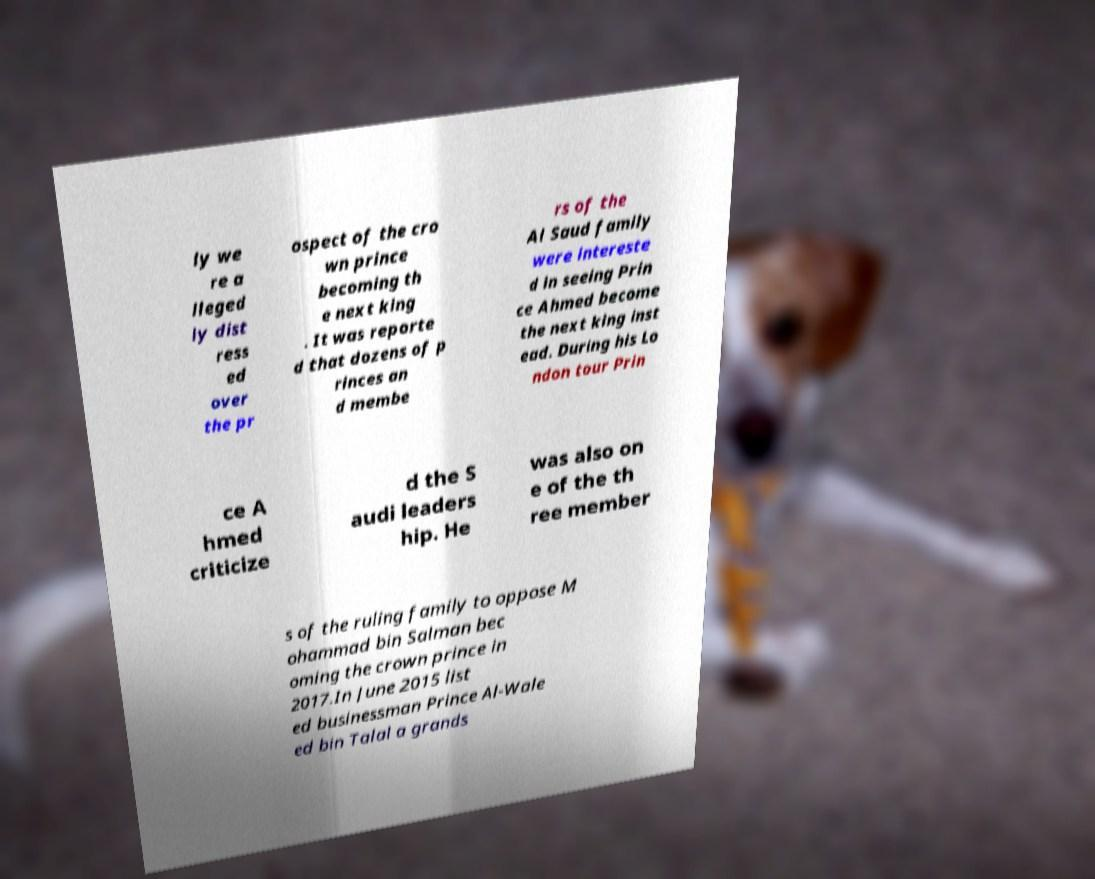For documentation purposes, I need the text within this image transcribed. Could you provide that? ly we re a lleged ly dist ress ed over the pr ospect of the cro wn prince becoming th e next king . It was reporte d that dozens of p rinces an d membe rs of the Al Saud family were intereste d in seeing Prin ce Ahmed become the next king inst ead. During his Lo ndon tour Prin ce A hmed criticize d the S audi leaders hip. He was also on e of the th ree member s of the ruling family to oppose M ohammad bin Salman bec oming the crown prince in 2017.In June 2015 list ed businessman Prince Al-Wale ed bin Talal a grands 